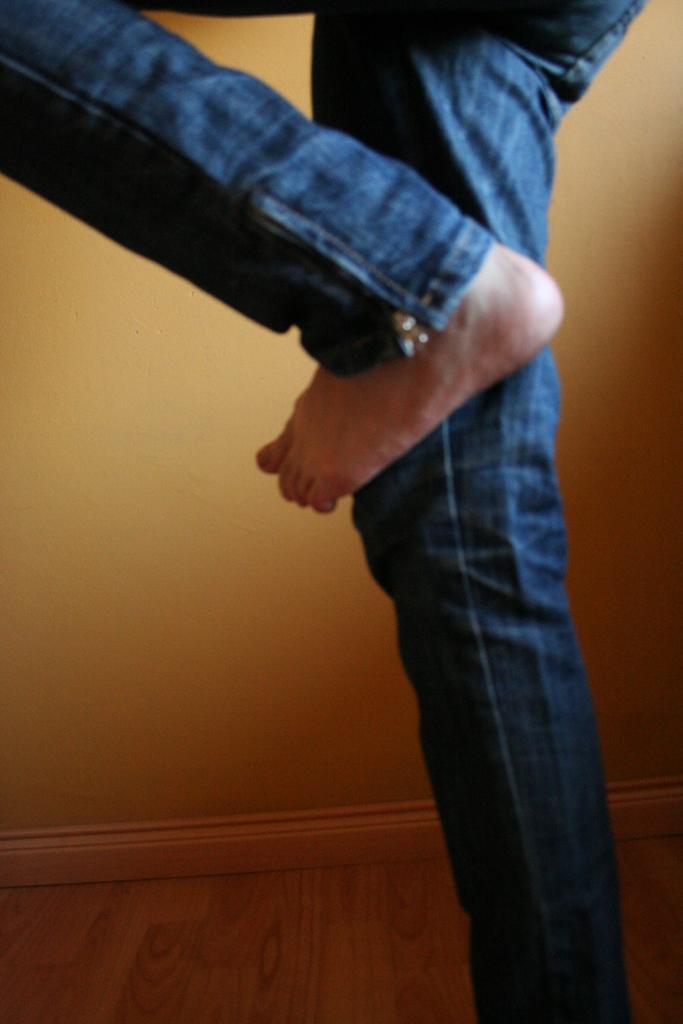How would you summarize this image in a sentence or two? In this image I can see legs of a person. The person is wearing blue jeans. In the background I can see a wall. 